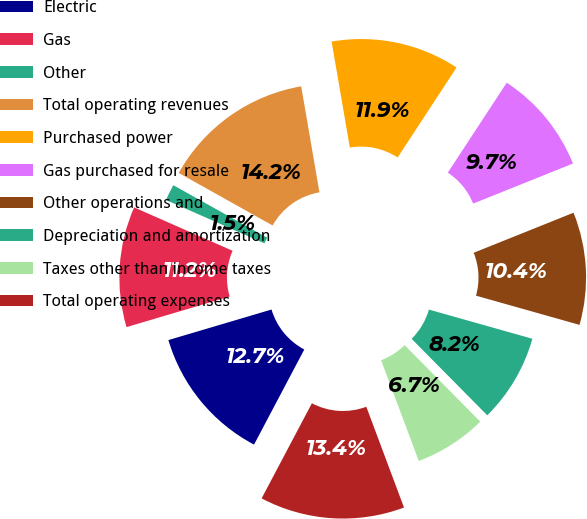Convert chart to OTSL. <chart><loc_0><loc_0><loc_500><loc_500><pie_chart><fcel>Electric<fcel>Gas<fcel>Other<fcel>Total operating revenues<fcel>Purchased power<fcel>Gas purchased for resale<fcel>Other operations and<fcel>Depreciation and amortization<fcel>Taxes other than income taxes<fcel>Total operating expenses<nl><fcel>12.68%<fcel>11.19%<fcel>1.51%<fcel>14.17%<fcel>11.94%<fcel>9.7%<fcel>10.45%<fcel>8.21%<fcel>6.72%<fcel>13.43%<nl></chart> 